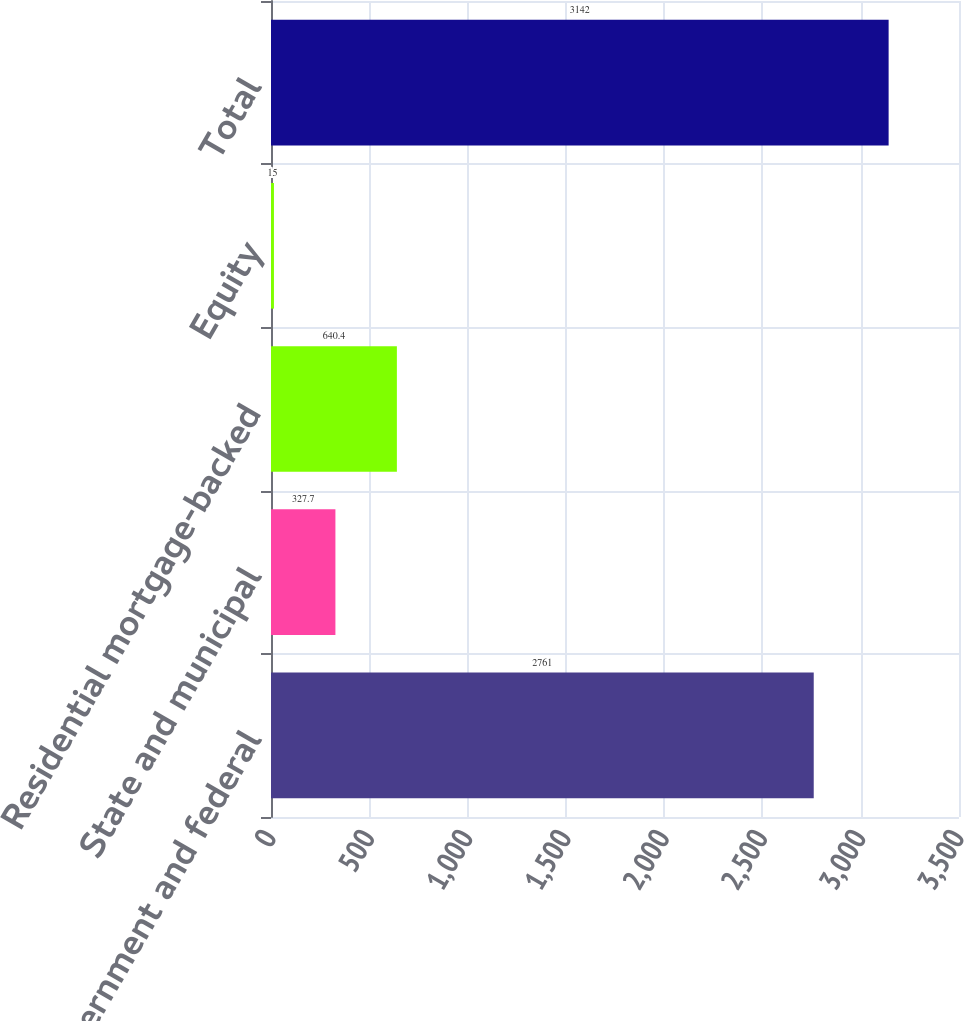<chart> <loc_0><loc_0><loc_500><loc_500><bar_chart><fcel>US government and federal<fcel>State and municipal<fcel>Residential mortgage-backed<fcel>Equity<fcel>Total<nl><fcel>2761<fcel>327.7<fcel>640.4<fcel>15<fcel>3142<nl></chart> 